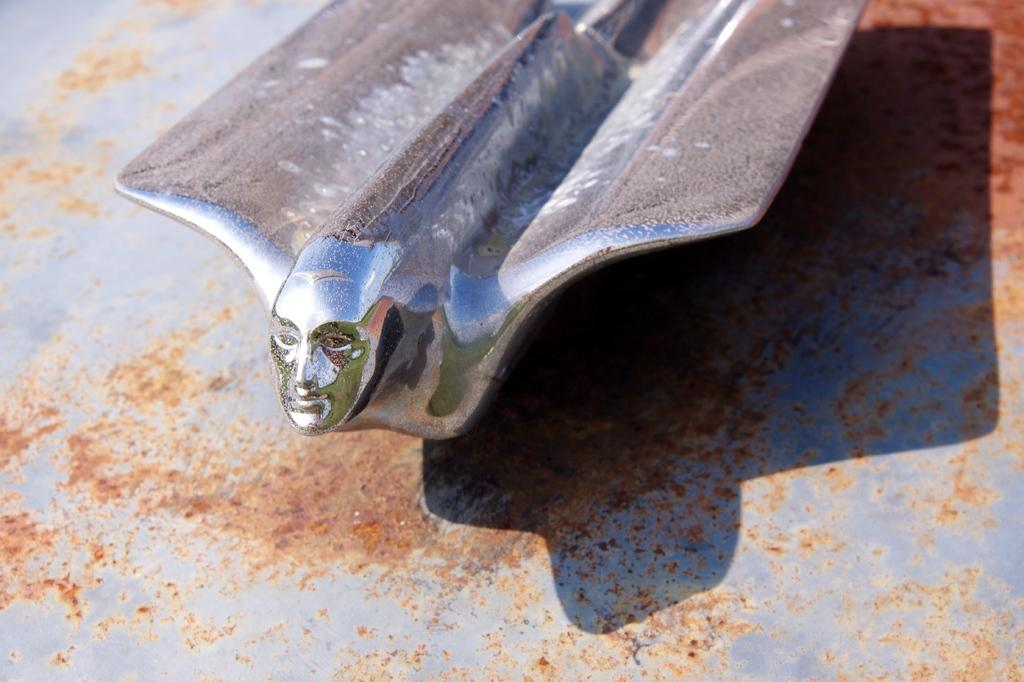What material is the object on the floor in the image made of? The object on the floor is made of metal. What design or pattern is visible on the metal sheet? The metal sheet has a face print on the front. Where is the metal sheet located in the image? The metal sheet is on the floor. What is the title of the basketball game being played in the image? There is no basketball game present in the image, so there is no title to be mentioned. 